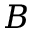Convert formula to latex. <formula><loc_0><loc_0><loc_500><loc_500>B</formula> 